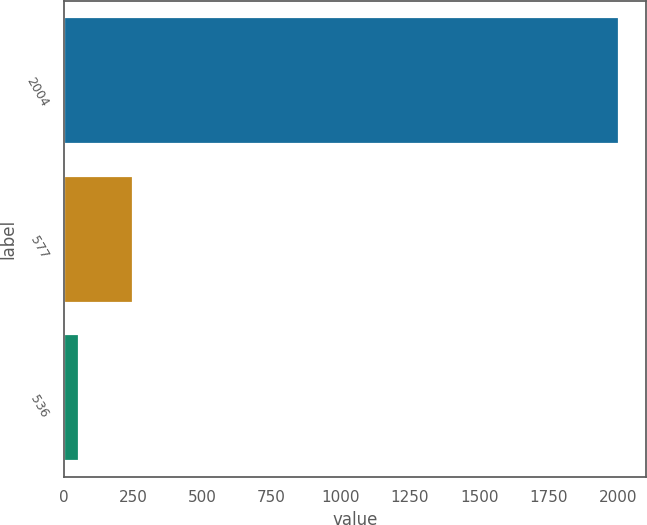<chart> <loc_0><loc_0><loc_500><loc_500><bar_chart><fcel>2004<fcel>577<fcel>536<nl><fcel>2003<fcel>251.6<fcel>57<nl></chart> 